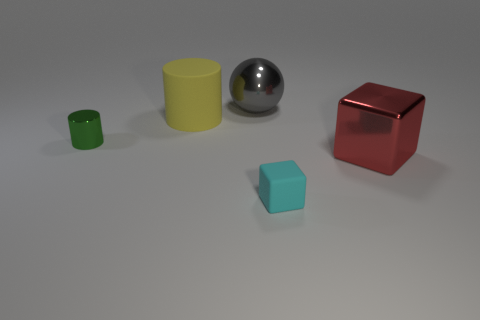Add 4 large yellow metallic objects. How many objects exist? 9 Subtract all balls. How many objects are left? 4 Add 5 green objects. How many green objects exist? 6 Subtract 0 red balls. How many objects are left? 5 Subtract all purple cubes. Subtract all small cyan cubes. How many objects are left? 4 Add 1 shiny objects. How many shiny objects are left? 4 